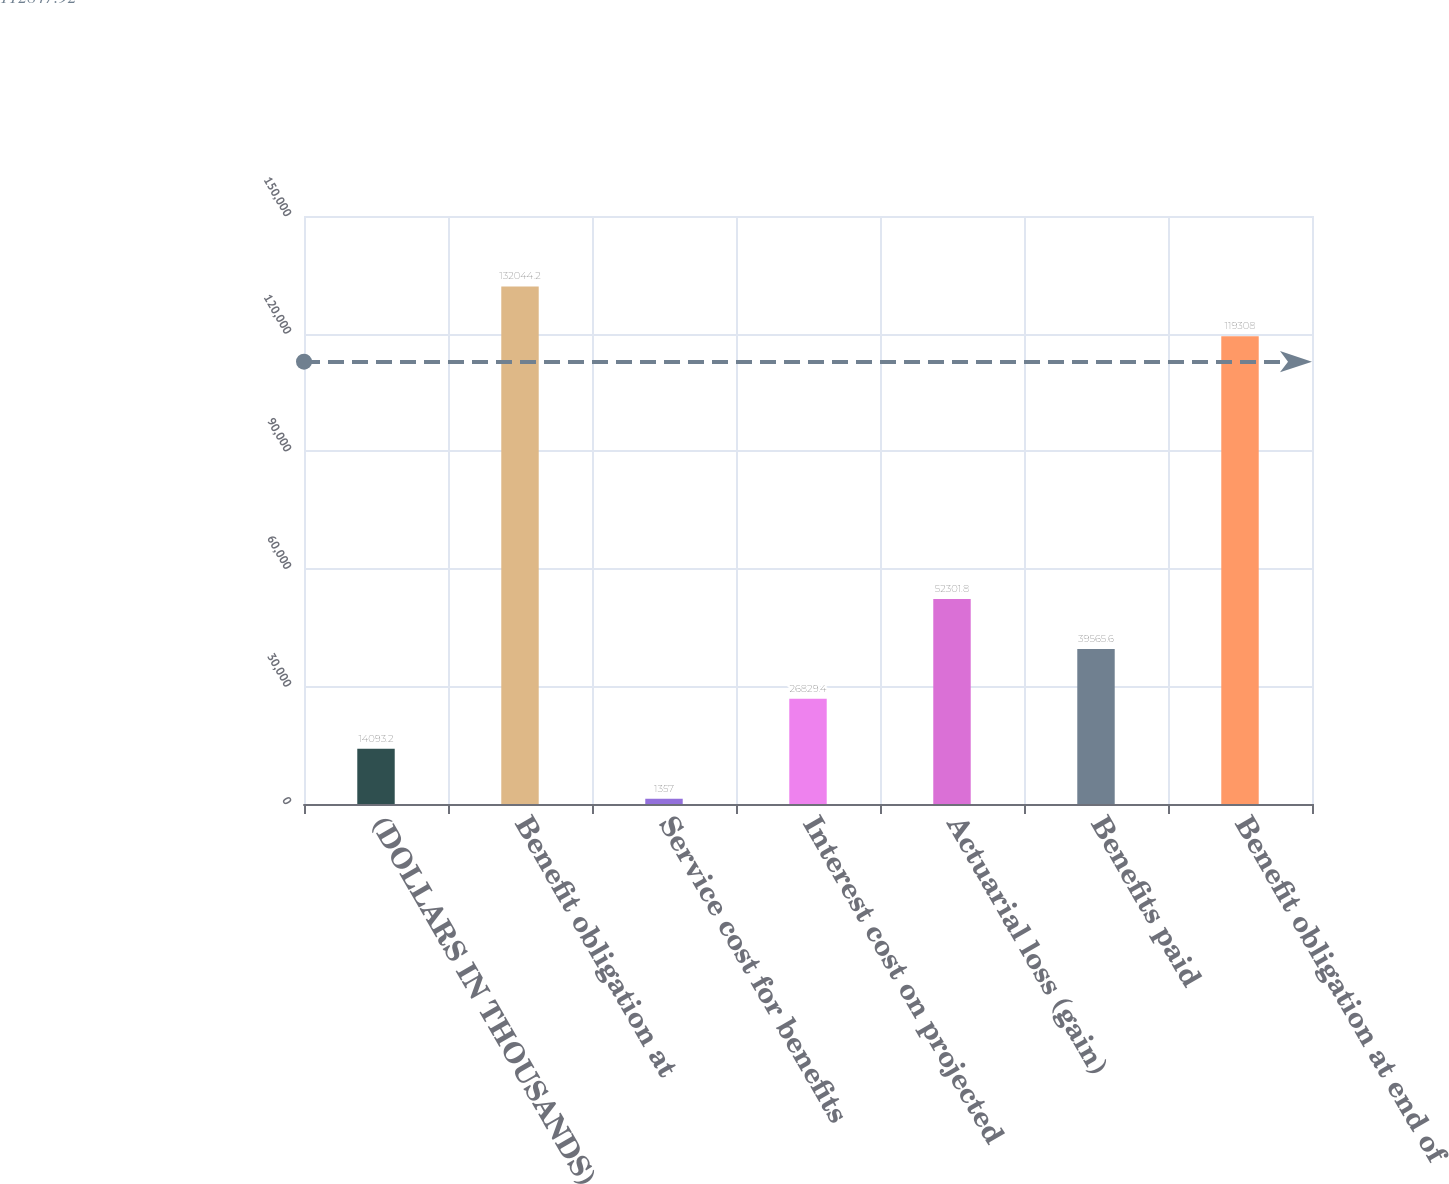Convert chart to OTSL. <chart><loc_0><loc_0><loc_500><loc_500><bar_chart><fcel>(DOLLARS IN THOUSANDS)<fcel>Benefit obligation at<fcel>Service cost for benefits<fcel>Interest cost on projected<fcel>Actuarial loss (gain)<fcel>Benefits paid<fcel>Benefit obligation at end of<nl><fcel>14093.2<fcel>132044<fcel>1357<fcel>26829.4<fcel>52301.8<fcel>39565.6<fcel>119308<nl></chart> 